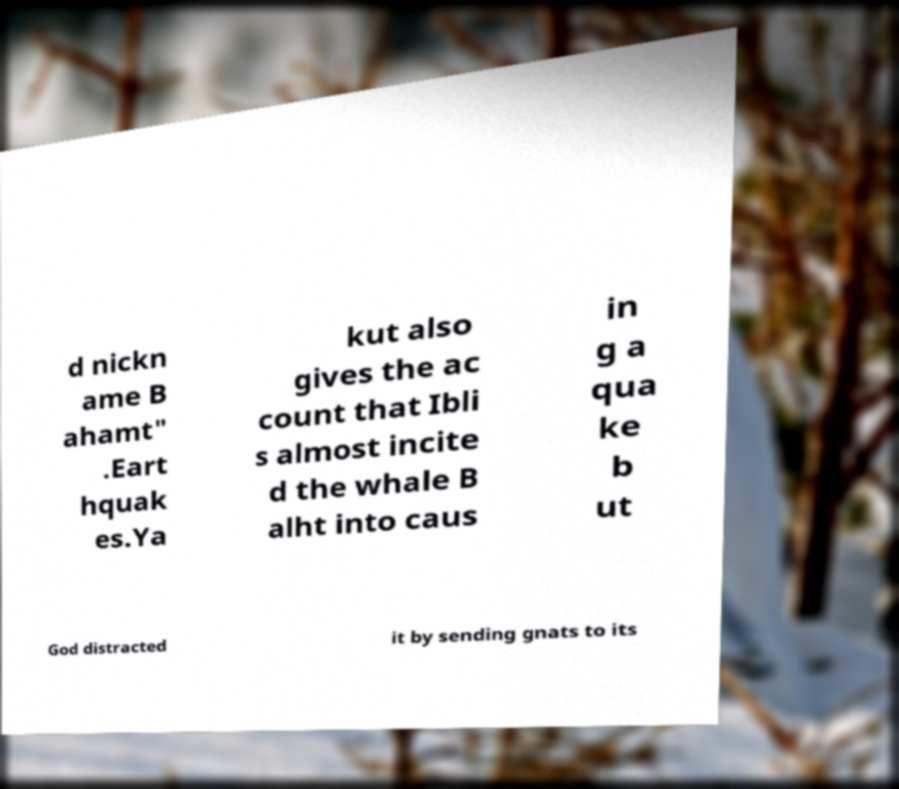Can you accurately transcribe the text from the provided image for me? d nickn ame B ahamt" .Eart hquak es.Ya kut also gives the ac count that Ibli s almost incite d the whale B alht into caus in g a qua ke b ut God distracted it by sending gnats to its 